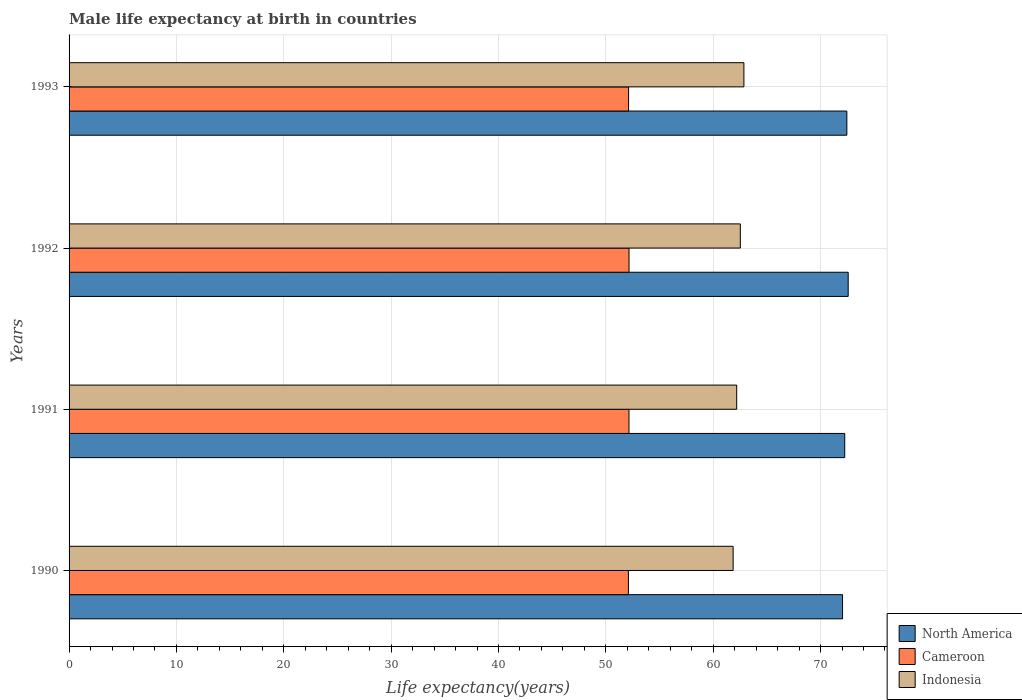How many different coloured bars are there?
Your response must be concise. 3. How many groups of bars are there?
Keep it short and to the point. 4. Are the number of bars per tick equal to the number of legend labels?
Your answer should be compact. Yes. Are the number of bars on each tick of the Y-axis equal?
Offer a terse response. Yes. How many bars are there on the 2nd tick from the top?
Make the answer very short. 3. What is the label of the 4th group of bars from the top?
Keep it short and to the point. 1990. In how many cases, is the number of bars for a given year not equal to the number of legend labels?
Your answer should be very brief. 0. What is the male life expectancy at birth in North America in 1990?
Your answer should be compact. 72.05. Across all years, what is the maximum male life expectancy at birth in Cameroon?
Give a very brief answer. 52.16. Across all years, what is the minimum male life expectancy at birth in North America?
Keep it short and to the point. 72.05. In which year was the male life expectancy at birth in Indonesia maximum?
Keep it short and to the point. 1993. In which year was the male life expectancy at birth in Cameroon minimum?
Ensure brevity in your answer.  1990. What is the total male life expectancy at birth in Indonesia in the graph?
Your answer should be very brief. 249.43. What is the difference between the male life expectancy at birth in Indonesia in 1992 and that in 1993?
Give a very brief answer. -0.34. What is the difference between the male life expectancy at birth in Cameroon in 1993 and the male life expectancy at birth in North America in 1992?
Provide a short and direct response. -20.46. What is the average male life expectancy at birth in Cameroon per year?
Keep it short and to the point. 52.13. In the year 1991, what is the difference between the male life expectancy at birth in Cameroon and male life expectancy at birth in North America?
Give a very brief answer. -20.1. What is the ratio of the male life expectancy at birth in Cameroon in 1992 to that in 1993?
Make the answer very short. 1. Is the male life expectancy at birth in Indonesia in 1990 less than that in 1991?
Your answer should be very brief. Yes. What is the difference between the highest and the second highest male life expectancy at birth in Cameroon?
Make the answer very short. 0. What is the difference between the highest and the lowest male life expectancy at birth in Indonesia?
Ensure brevity in your answer.  1. Is the sum of the male life expectancy at birth in North America in 1990 and 1993 greater than the maximum male life expectancy at birth in Cameroon across all years?
Your response must be concise. Yes. What does the 1st bar from the bottom in 1992 represents?
Keep it short and to the point. North America. Is it the case that in every year, the sum of the male life expectancy at birth in North America and male life expectancy at birth in Indonesia is greater than the male life expectancy at birth in Cameroon?
Ensure brevity in your answer.  Yes. How many years are there in the graph?
Keep it short and to the point. 4. Does the graph contain any zero values?
Keep it short and to the point. No. Does the graph contain grids?
Provide a short and direct response. Yes. How many legend labels are there?
Make the answer very short. 3. What is the title of the graph?
Give a very brief answer. Male life expectancy at birth in countries. Does "Cyprus" appear as one of the legend labels in the graph?
Provide a succinct answer. No. What is the label or title of the X-axis?
Offer a terse response. Life expectancy(years). What is the Life expectancy(years) of North America in 1990?
Make the answer very short. 72.05. What is the Life expectancy(years) of Cameroon in 1990?
Offer a very short reply. 52.1. What is the Life expectancy(years) of Indonesia in 1990?
Offer a terse response. 61.86. What is the Life expectancy(years) of North America in 1991?
Make the answer very short. 72.25. What is the Life expectancy(years) of Cameroon in 1991?
Keep it short and to the point. 52.16. What is the Life expectancy(years) of Indonesia in 1991?
Make the answer very short. 62.19. What is the Life expectancy(years) of North America in 1992?
Provide a succinct answer. 72.57. What is the Life expectancy(years) in Cameroon in 1992?
Your answer should be very brief. 52.16. What is the Life expectancy(years) of Indonesia in 1992?
Your answer should be compact. 62.52. What is the Life expectancy(years) of North America in 1993?
Provide a short and direct response. 72.45. What is the Life expectancy(years) in Cameroon in 1993?
Offer a very short reply. 52.12. What is the Life expectancy(years) of Indonesia in 1993?
Your response must be concise. 62.86. Across all years, what is the maximum Life expectancy(years) in North America?
Offer a very short reply. 72.57. Across all years, what is the maximum Life expectancy(years) of Cameroon?
Your response must be concise. 52.16. Across all years, what is the maximum Life expectancy(years) in Indonesia?
Offer a very short reply. 62.86. Across all years, what is the minimum Life expectancy(years) of North America?
Make the answer very short. 72.05. Across all years, what is the minimum Life expectancy(years) of Cameroon?
Offer a very short reply. 52.1. Across all years, what is the minimum Life expectancy(years) of Indonesia?
Make the answer very short. 61.86. What is the total Life expectancy(years) of North America in the graph?
Provide a succinct answer. 289.33. What is the total Life expectancy(years) of Cameroon in the graph?
Ensure brevity in your answer.  208.53. What is the total Life expectancy(years) of Indonesia in the graph?
Offer a very short reply. 249.43. What is the difference between the Life expectancy(years) in North America in 1990 and that in 1991?
Your response must be concise. -0.2. What is the difference between the Life expectancy(years) in Cameroon in 1990 and that in 1991?
Provide a short and direct response. -0.05. What is the difference between the Life expectancy(years) of Indonesia in 1990 and that in 1991?
Your answer should be very brief. -0.33. What is the difference between the Life expectancy(years) of North America in 1990 and that in 1992?
Keep it short and to the point. -0.53. What is the difference between the Life expectancy(years) in Cameroon in 1990 and that in 1992?
Your answer should be very brief. -0.06. What is the difference between the Life expectancy(years) of Indonesia in 1990 and that in 1992?
Your answer should be compact. -0.67. What is the difference between the Life expectancy(years) of North America in 1990 and that in 1993?
Provide a succinct answer. -0.4. What is the difference between the Life expectancy(years) of Cameroon in 1990 and that in 1993?
Keep it short and to the point. -0.02. What is the difference between the Life expectancy(years) of Indonesia in 1990 and that in 1993?
Your response must be concise. -1. What is the difference between the Life expectancy(years) in North America in 1991 and that in 1992?
Offer a terse response. -0.32. What is the difference between the Life expectancy(years) in Cameroon in 1991 and that in 1992?
Your answer should be compact. -0.01. What is the difference between the Life expectancy(years) in Indonesia in 1991 and that in 1992?
Keep it short and to the point. -0.34. What is the difference between the Life expectancy(years) of North America in 1991 and that in 1993?
Provide a short and direct response. -0.2. What is the difference between the Life expectancy(years) of Cameroon in 1991 and that in 1993?
Keep it short and to the point. 0.04. What is the difference between the Life expectancy(years) of Indonesia in 1991 and that in 1993?
Provide a succinct answer. -0.67. What is the difference between the Life expectancy(years) of North America in 1992 and that in 1993?
Offer a very short reply. 0.12. What is the difference between the Life expectancy(years) of Cameroon in 1992 and that in 1993?
Your answer should be compact. 0.04. What is the difference between the Life expectancy(years) of Indonesia in 1992 and that in 1993?
Offer a very short reply. -0.34. What is the difference between the Life expectancy(years) of North America in 1990 and the Life expectancy(years) of Cameroon in 1991?
Give a very brief answer. 19.89. What is the difference between the Life expectancy(years) of North America in 1990 and the Life expectancy(years) of Indonesia in 1991?
Your response must be concise. 9.86. What is the difference between the Life expectancy(years) of Cameroon in 1990 and the Life expectancy(years) of Indonesia in 1991?
Provide a short and direct response. -10.09. What is the difference between the Life expectancy(years) of North America in 1990 and the Life expectancy(years) of Cameroon in 1992?
Provide a short and direct response. 19.89. What is the difference between the Life expectancy(years) in North America in 1990 and the Life expectancy(years) in Indonesia in 1992?
Your answer should be compact. 9.52. What is the difference between the Life expectancy(years) of Cameroon in 1990 and the Life expectancy(years) of Indonesia in 1992?
Make the answer very short. -10.42. What is the difference between the Life expectancy(years) in North America in 1990 and the Life expectancy(years) in Cameroon in 1993?
Provide a short and direct response. 19.93. What is the difference between the Life expectancy(years) in North America in 1990 and the Life expectancy(years) in Indonesia in 1993?
Your response must be concise. 9.19. What is the difference between the Life expectancy(years) of Cameroon in 1990 and the Life expectancy(years) of Indonesia in 1993?
Provide a succinct answer. -10.76. What is the difference between the Life expectancy(years) of North America in 1991 and the Life expectancy(years) of Cameroon in 1992?
Your answer should be compact. 20.09. What is the difference between the Life expectancy(years) in North America in 1991 and the Life expectancy(years) in Indonesia in 1992?
Offer a terse response. 9.73. What is the difference between the Life expectancy(years) of Cameroon in 1991 and the Life expectancy(years) of Indonesia in 1992?
Make the answer very short. -10.37. What is the difference between the Life expectancy(years) in North America in 1991 and the Life expectancy(years) in Cameroon in 1993?
Make the answer very short. 20.13. What is the difference between the Life expectancy(years) of North America in 1991 and the Life expectancy(years) of Indonesia in 1993?
Offer a terse response. 9.39. What is the difference between the Life expectancy(years) of Cameroon in 1991 and the Life expectancy(years) of Indonesia in 1993?
Provide a succinct answer. -10.71. What is the difference between the Life expectancy(years) of North America in 1992 and the Life expectancy(years) of Cameroon in 1993?
Provide a succinct answer. 20.46. What is the difference between the Life expectancy(years) of North America in 1992 and the Life expectancy(years) of Indonesia in 1993?
Your response must be concise. 9.71. What is the difference between the Life expectancy(years) of Cameroon in 1992 and the Life expectancy(years) of Indonesia in 1993?
Your response must be concise. -10.7. What is the average Life expectancy(years) of North America per year?
Ensure brevity in your answer.  72.33. What is the average Life expectancy(years) in Cameroon per year?
Your answer should be compact. 52.13. What is the average Life expectancy(years) in Indonesia per year?
Provide a succinct answer. 62.36. In the year 1990, what is the difference between the Life expectancy(years) of North America and Life expectancy(years) of Cameroon?
Offer a very short reply. 19.95. In the year 1990, what is the difference between the Life expectancy(years) in North America and Life expectancy(years) in Indonesia?
Your answer should be very brief. 10.19. In the year 1990, what is the difference between the Life expectancy(years) of Cameroon and Life expectancy(years) of Indonesia?
Provide a succinct answer. -9.75. In the year 1991, what is the difference between the Life expectancy(years) of North America and Life expectancy(years) of Cameroon?
Your answer should be compact. 20.1. In the year 1991, what is the difference between the Life expectancy(years) in North America and Life expectancy(years) in Indonesia?
Your response must be concise. 10.06. In the year 1991, what is the difference between the Life expectancy(years) of Cameroon and Life expectancy(years) of Indonesia?
Keep it short and to the point. -10.03. In the year 1992, what is the difference between the Life expectancy(years) of North America and Life expectancy(years) of Cameroon?
Your answer should be very brief. 20.41. In the year 1992, what is the difference between the Life expectancy(years) of North America and Life expectancy(years) of Indonesia?
Keep it short and to the point. 10.05. In the year 1992, what is the difference between the Life expectancy(years) in Cameroon and Life expectancy(years) in Indonesia?
Your answer should be compact. -10.37. In the year 1993, what is the difference between the Life expectancy(years) in North America and Life expectancy(years) in Cameroon?
Your response must be concise. 20.33. In the year 1993, what is the difference between the Life expectancy(years) of North America and Life expectancy(years) of Indonesia?
Provide a succinct answer. 9.59. In the year 1993, what is the difference between the Life expectancy(years) of Cameroon and Life expectancy(years) of Indonesia?
Make the answer very short. -10.74. What is the ratio of the Life expectancy(years) of North America in 1990 to that in 1992?
Give a very brief answer. 0.99. What is the ratio of the Life expectancy(years) of Indonesia in 1990 to that in 1992?
Offer a terse response. 0.99. What is the ratio of the Life expectancy(years) in North America in 1990 to that in 1993?
Offer a terse response. 0.99. What is the ratio of the Life expectancy(years) of Cameroon in 1990 to that in 1993?
Offer a terse response. 1. What is the ratio of the Life expectancy(years) of Indonesia in 1990 to that in 1993?
Keep it short and to the point. 0.98. What is the ratio of the Life expectancy(years) in Cameroon in 1991 to that in 1992?
Offer a terse response. 1. What is the ratio of the Life expectancy(years) of Indonesia in 1991 to that in 1992?
Provide a succinct answer. 0.99. What is the ratio of the Life expectancy(years) in North America in 1991 to that in 1993?
Keep it short and to the point. 1. What is the ratio of the Life expectancy(years) in Cameroon in 1991 to that in 1993?
Provide a short and direct response. 1. What is the ratio of the Life expectancy(years) in Indonesia in 1991 to that in 1993?
Your answer should be compact. 0.99. What is the ratio of the Life expectancy(years) in Cameroon in 1992 to that in 1993?
Provide a succinct answer. 1. What is the ratio of the Life expectancy(years) in Indonesia in 1992 to that in 1993?
Provide a short and direct response. 0.99. What is the difference between the highest and the second highest Life expectancy(years) in North America?
Offer a terse response. 0.12. What is the difference between the highest and the second highest Life expectancy(years) in Cameroon?
Give a very brief answer. 0.01. What is the difference between the highest and the second highest Life expectancy(years) of Indonesia?
Your response must be concise. 0.34. What is the difference between the highest and the lowest Life expectancy(years) in North America?
Provide a short and direct response. 0.53. What is the difference between the highest and the lowest Life expectancy(years) in Cameroon?
Your answer should be compact. 0.06. 